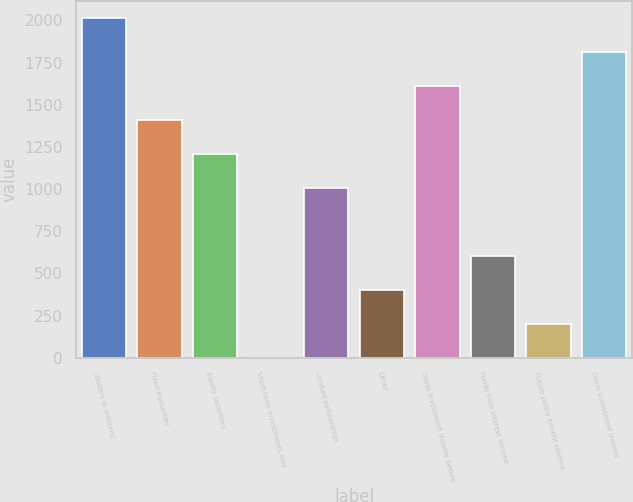<chart> <loc_0><loc_0><loc_500><loc_500><bar_chart><fcel>(Dollars in millions)<fcel>Fixed maturities<fcel>Equity securities<fcel>Short-term investments and<fcel>Limited partnerships<fcel>Other<fcel>Gross investment income before<fcel>Funds held interest income<fcel>Future policy benefit reserve<fcel>Gross investment income<nl><fcel>2014<fcel>1410.25<fcel>1209<fcel>1.5<fcel>1007.75<fcel>404<fcel>1611.5<fcel>605.25<fcel>202.75<fcel>1812.75<nl></chart> 